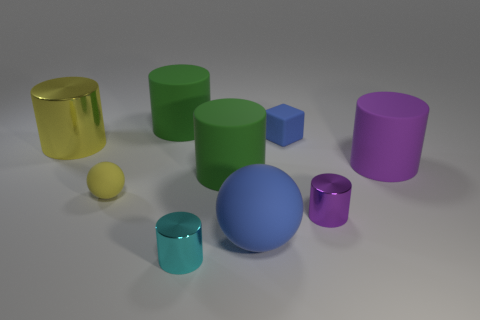Subtract all small cyan cylinders. How many cylinders are left? 5 Subtract all yellow cylinders. How many cylinders are left? 5 Subtract all blue cylinders. Subtract all yellow blocks. How many cylinders are left? 6 Subtract all spheres. How many objects are left? 7 Subtract all metal cylinders. Subtract all tiny yellow objects. How many objects are left? 5 Add 1 blue cubes. How many blue cubes are left? 2 Add 2 large blue objects. How many large blue objects exist? 3 Subtract 1 blue cubes. How many objects are left? 8 